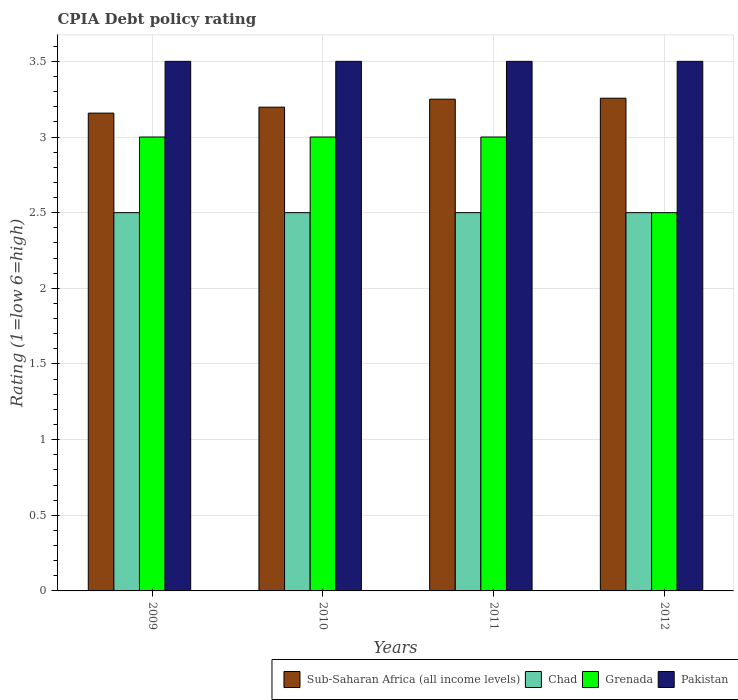What is the CPIA rating in Grenada in 2012?
Your answer should be compact. 2.5. Across all years, what is the maximum CPIA rating in Sub-Saharan Africa (all income levels)?
Offer a very short reply. 3.26. Across all years, what is the minimum CPIA rating in Sub-Saharan Africa (all income levels)?
Provide a succinct answer. 3.16. What is the difference between the CPIA rating in Sub-Saharan Africa (all income levels) in 2011 and that in 2012?
Ensure brevity in your answer.  -0.01. What is the average CPIA rating in Grenada per year?
Your response must be concise. 2.88. In the year 2012, what is the difference between the CPIA rating in Grenada and CPIA rating in Sub-Saharan Africa (all income levels)?
Your answer should be very brief. -0.76. What is the ratio of the CPIA rating in Sub-Saharan Africa (all income levels) in 2010 to that in 2012?
Keep it short and to the point. 0.98. Is the CPIA rating in Chad in 2010 less than that in 2012?
Give a very brief answer. No. Is the difference between the CPIA rating in Grenada in 2009 and 2012 greater than the difference between the CPIA rating in Sub-Saharan Africa (all income levels) in 2009 and 2012?
Ensure brevity in your answer.  Yes. What is the difference between the highest and the second highest CPIA rating in Sub-Saharan Africa (all income levels)?
Provide a short and direct response. 0.01. In how many years, is the CPIA rating in Pakistan greater than the average CPIA rating in Pakistan taken over all years?
Keep it short and to the point. 0. Is it the case that in every year, the sum of the CPIA rating in Grenada and CPIA rating in Chad is greater than the sum of CPIA rating in Sub-Saharan Africa (all income levels) and CPIA rating in Pakistan?
Offer a very short reply. No. What does the 3rd bar from the right in 2011 represents?
Your response must be concise. Chad. What is the difference between two consecutive major ticks on the Y-axis?
Ensure brevity in your answer.  0.5. How many legend labels are there?
Your answer should be compact. 4. How are the legend labels stacked?
Offer a terse response. Horizontal. What is the title of the graph?
Your answer should be very brief. CPIA Debt policy rating. Does "Small states" appear as one of the legend labels in the graph?
Provide a succinct answer. No. What is the label or title of the Y-axis?
Offer a terse response. Rating (1=low 6=high). What is the Rating (1=low 6=high) of Sub-Saharan Africa (all income levels) in 2009?
Your answer should be very brief. 3.16. What is the Rating (1=low 6=high) of Chad in 2009?
Offer a terse response. 2.5. What is the Rating (1=low 6=high) of Grenada in 2009?
Give a very brief answer. 3. What is the Rating (1=low 6=high) of Pakistan in 2009?
Your answer should be very brief. 3.5. What is the Rating (1=low 6=high) of Sub-Saharan Africa (all income levels) in 2010?
Your answer should be compact. 3.2. What is the Rating (1=low 6=high) in Grenada in 2010?
Your answer should be very brief. 3. What is the Rating (1=low 6=high) of Sub-Saharan Africa (all income levels) in 2011?
Provide a short and direct response. 3.25. What is the Rating (1=low 6=high) in Chad in 2011?
Your answer should be very brief. 2.5. What is the Rating (1=low 6=high) in Pakistan in 2011?
Provide a short and direct response. 3.5. What is the Rating (1=low 6=high) in Sub-Saharan Africa (all income levels) in 2012?
Offer a terse response. 3.26. Across all years, what is the maximum Rating (1=low 6=high) in Sub-Saharan Africa (all income levels)?
Offer a very short reply. 3.26. Across all years, what is the minimum Rating (1=low 6=high) in Sub-Saharan Africa (all income levels)?
Keep it short and to the point. 3.16. Across all years, what is the minimum Rating (1=low 6=high) in Chad?
Your answer should be compact. 2.5. Across all years, what is the minimum Rating (1=low 6=high) of Pakistan?
Provide a succinct answer. 3.5. What is the total Rating (1=low 6=high) in Sub-Saharan Africa (all income levels) in the graph?
Your response must be concise. 12.86. What is the difference between the Rating (1=low 6=high) in Sub-Saharan Africa (all income levels) in 2009 and that in 2010?
Your answer should be compact. -0.04. What is the difference between the Rating (1=low 6=high) in Pakistan in 2009 and that in 2010?
Ensure brevity in your answer.  0. What is the difference between the Rating (1=low 6=high) of Sub-Saharan Africa (all income levels) in 2009 and that in 2011?
Offer a terse response. -0.09. What is the difference between the Rating (1=low 6=high) of Grenada in 2009 and that in 2011?
Make the answer very short. 0. What is the difference between the Rating (1=low 6=high) in Pakistan in 2009 and that in 2011?
Your answer should be compact. 0. What is the difference between the Rating (1=low 6=high) of Sub-Saharan Africa (all income levels) in 2009 and that in 2012?
Provide a succinct answer. -0.1. What is the difference between the Rating (1=low 6=high) in Chad in 2009 and that in 2012?
Provide a short and direct response. 0. What is the difference between the Rating (1=low 6=high) of Grenada in 2009 and that in 2012?
Offer a very short reply. 0.5. What is the difference between the Rating (1=low 6=high) in Pakistan in 2009 and that in 2012?
Offer a terse response. 0. What is the difference between the Rating (1=low 6=high) of Sub-Saharan Africa (all income levels) in 2010 and that in 2011?
Offer a very short reply. -0.05. What is the difference between the Rating (1=low 6=high) of Chad in 2010 and that in 2011?
Your answer should be compact. 0. What is the difference between the Rating (1=low 6=high) in Grenada in 2010 and that in 2011?
Provide a short and direct response. 0. What is the difference between the Rating (1=low 6=high) of Sub-Saharan Africa (all income levels) in 2010 and that in 2012?
Keep it short and to the point. -0.06. What is the difference between the Rating (1=low 6=high) in Chad in 2010 and that in 2012?
Provide a succinct answer. 0. What is the difference between the Rating (1=low 6=high) of Grenada in 2010 and that in 2012?
Ensure brevity in your answer.  0.5. What is the difference between the Rating (1=low 6=high) of Pakistan in 2010 and that in 2012?
Make the answer very short. 0. What is the difference between the Rating (1=low 6=high) of Sub-Saharan Africa (all income levels) in 2011 and that in 2012?
Keep it short and to the point. -0.01. What is the difference between the Rating (1=low 6=high) of Pakistan in 2011 and that in 2012?
Give a very brief answer. 0. What is the difference between the Rating (1=low 6=high) in Sub-Saharan Africa (all income levels) in 2009 and the Rating (1=low 6=high) in Chad in 2010?
Offer a very short reply. 0.66. What is the difference between the Rating (1=low 6=high) of Sub-Saharan Africa (all income levels) in 2009 and the Rating (1=low 6=high) of Grenada in 2010?
Provide a succinct answer. 0.16. What is the difference between the Rating (1=low 6=high) of Sub-Saharan Africa (all income levels) in 2009 and the Rating (1=low 6=high) of Pakistan in 2010?
Provide a succinct answer. -0.34. What is the difference between the Rating (1=low 6=high) of Chad in 2009 and the Rating (1=low 6=high) of Grenada in 2010?
Your answer should be very brief. -0.5. What is the difference between the Rating (1=low 6=high) of Sub-Saharan Africa (all income levels) in 2009 and the Rating (1=low 6=high) of Chad in 2011?
Provide a succinct answer. 0.66. What is the difference between the Rating (1=low 6=high) of Sub-Saharan Africa (all income levels) in 2009 and the Rating (1=low 6=high) of Grenada in 2011?
Offer a very short reply. 0.16. What is the difference between the Rating (1=low 6=high) of Sub-Saharan Africa (all income levels) in 2009 and the Rating (1=low 6=high) of Pakistan in 2011?
Your response must be concise. -0.34. What is the difference between the Rating (1=low 6=high) of Chad in 2009 and the Rating (1=low 6=high) of Grenada in 2011?
Provide a short and direct response. -0.5. What is the difference between the Rating (1=low 6=high) of Grenada in 2009 and the Rating (1=low 6=high) of Pakistan in 2011?
Ensure brevity in your answer.  -0.5. What is the difference between the Rating (1=low 6=high) of Sub-Saharan Africa (all income levels) in 2009 and the Rating (1=low 6=high) of Chad in 2012?
Provide a short and direct response. 0.66. What is the difference between the Rating (1=low 6=high) in Sub-Saharan Africa (all income levels) in 2009 and the Rating (1=low 6=high) in Grenada in 2012?
Make the answer very short. 0.66. What is the difference between the Rating (1=low 6=high) in Sub-Saharan Africa (all income levels) in 2009 and the Rating (1=low 6=high) in Pakistan in 2012?
Your response must be concise. -0.34. What is the difference between the Rating (1=low 6=high) of Chad in 2009 and the Rating (1=low 6=high) of Pakistan in 2012?
Your answer should be compact. -1. What is the difference between the Rating (1=low 6=high) in Sub-Saharan Africa (all income levels) in 2010 and the Rating (1=low 6=high) in Chad in 2011?
Ensure brevity in your answer.  0.7. What is the difference between the Rating (1=low 6=high) in Sub-Saharan Africa (all income levels) in 2010 and the Rating (1=low 6=high) in Grenada in 2011?
Offer a very short reply. 0.2. What is the difference between the Rating (1=low 6=high) of Sub-Saharan Africa (all income levels) in 2010 and the Rating (1=low 6=high) of Pakistan in 2011?
Give a very brief answer. -0.3. What is the difference between the Rating (1=low 6=high) in Chad in 2010 and the Rating (1=low 6=high) in Grenada in 2011?
Provide a short and direct response. -0.5. What is the difference between the Rating (1=low 6=high) in Grenada in 2010 and the Rating (1=low 6=high) in Pakistan in 2011?
Your response must be concise. -0.5. What is the difference between the Rating (1=low 6=high) of Sub-Saharan Africa (all income levels) in 2010 and the Rating (1=low 6=high) of Chad in 2012?
Offer a very short reply. 0.7. What is the difference between the Rating (1=low 6=high) in Sub-Saharan Africa (all income levels) in 2010 and the Rating (1=low 6=high) in Grenada in 2012?
Ensure brevity in your answer.  0.7. What is the difference between the Rating (1=low 6=high) of Sub-Saharan Africa (all income levels) in 2010 and the Rating (1=low 6=high) of Pakistan in 2012?
Keep it short and to the point. -0.3. What is the difference between the Rating (1=low 6=high) in Chad in 2010 and the Rating (1=low 6=high) in Grenada in 2012?
Ensure brevity in your answer.  0. What is the difference between the Rating (1=low 6=high) of Chad in 2010 and the Rating (1=low 6=high) of Pakistan in 2012?
Keep it short and to the point. -1. What is the difference between the Rating (1=low 6=high) of Grenada in 2010 and the Rating (1=low 6=high) of Pakistan in 2012?
Your answer should be compact. -0.5. What is the difference between the Rating (1=low 6=high) in Chad in 2011 and the Rating (1=low 6=high) in Pakistan in 2012?
Your answer should be compact. -1. What is the difference between the Rating (1=low 6=high) of Grenada in 2011 and the Rating (1=low 6=high) of Pakistan in 2012?
Offer a very short reply. -0.5. What is the average Rating (1=low 6=high) in Sub-Saharan Africa (all income levels) per year?
Ensure brevity in your answer.  3.22. What is the average Rating (1=low 6=high) in Grenada per year?
Provide a short and direct response. 2.88. What is the average Rating (1=low 6=high) of Pakistan per year?
Your answer should be compact. 3.5. In the year 2009, what is the difference between the Rating (1=low 6=high) in Sub-Saharan Africa (all income levels) and Rating (1=low 6=high) in Chad?
Your response must be concise. 0.66. In the year 2009, what is the difference between the Rating (1=low 6=high) in Sub-Saharan Africa (all income levels) and Rating (1=low 6=high) in Grenada?
Keep it short and to the point. 0.16. In the year 2009, what is the difference between the Rating (1=low 6=high) of Sub-Saharan Africa (all income levels) and Rating (1=low 6=high) of Pakistan?
Provide a short and direct response. -0.34. In the year 2009, what is the difference between the Rating (1=low 6=high) in Chad and Rating (1=low 6=high) in Pakistan?
Ensure brevity in your answer.  -1. In the year 2009, what is the difference between the Rating (1=low 6=high) of Grenada and Rating (1=low 6=high) of Pakistan?
Your answer should be very brief. -0.5. In the year 2010, what is the difference between the Rating (1=low 6=high) in Sub-Saharan Africa (all income levels) and Rating (1=low 6=high) in Chad?
Ensure brevity in your answer.  0.7. In the year 2010, what is the difference between the Rating (1=low 6=high) in Sub-Saharan Africa (all income levels) and Rating (1=low 6=high) in Grenada?
Provide a short and direct response. 0.2. In the year 2010, what is the difference between the Rating (1=low 6=high) of Sub-Saharan Africa (all income levels) and Rating (1=low 6=high) of Pakistan?
Offer a terse response. -0.3. In the year 2010, what is the difference between the Rating (1=low 6=high) in Chad and Rating (1=low 6=high) in Grenada?
Make the answer very short. -0.5. In the year 2011, what is the difference between the Rating (1=low 6=high) of Sub-Saharan Africa (all income levels) and Rating (1=low 6=high) of Pakistan?
Keep it short and to the point. -0.25. In the year 2012, what is the difference between the Rating (1=low 6=high) of Sub-Saharan Africa (all income levels) and Rating (1=low 6=high) of Chad?
Provide a succinct answer. 0.76. In the year 2012, what is the difference between the Rating (1=low 6=high) in Sub-Saharan Africa (all income levels) and Rating (1=low 6=high) in Grenada?
Your answer should be very brief. 0.76. In the year 2012, what is the difference between the Rating (1=low 6=high) in Sub-Saharan Africa (all income levels) and Rating (1=low 6=high) in Pakistan?
Offer a terse response. -0.24. In the year 2012, what is the difference between the Rating (1=low 6=high) in Chad and Rating (1=low 6=high) in Grenada?
Provide a short and direct response. 0. What is the ratio of the Rating (1=low 6=high) of Chad in 2009 to that in 2010?
Your answer should be very brief. 1. What is the ratio of the Rating (1=low 6=high) of Grenada in 2009 to that in 2010?
Offer a very short reply. 1. What is the ratio of the Rating (1=low 6=high) of Sub-Saharan Africa (all income levels) in 2009 to that in 2011?
Offer a very short reply. 0.97. What is the ratio of the Rating (1=low 6=high) in Chad in 2009 to that in 2011?
Your answer should be compact. 1. What is the ratio of the Rating (1=low 6=high) in Grenada in 2009 to that in 2011?
Give a very brief answer. 1. What is the ratio of the Rating (1=low 6=high) of Pakistan in 2009 to that in 2011?
Offer a terse response. 1. What is the ratio of the Rating (1=low 6=high) in Sub-Saharan Africa (all income levels) in 2009 to that in 2012?
Your response must be concise. 0.97. What is the ratio of the Rating (1=low 6=high) in Chad in 2009 to that in 2012?
Provide a short and direct response. 1. What is the ratio of the Rating (1=low 6=high) of Sub-Saharan Africa (all income levels) in 2010 to that in 2011?
Provide a short and direct response. 0.98. What is the ratio of the Rating (1=low 6=high) in Grenada in 2010 to that in 2011?
Make the answer very short. 1. What is the ratio of the Rating (1=low 6=high) in Sub-Saharan Africa (all income levels) in 2010 to that in 2012?
Give a very brief answer. 0.98. What is the ratio of the Rating (1=low 6=high) of Sub-Saharan Africa (all income levels) in 2011 to that in 2012?
Give a very brief answer. 1. What is the ratio of the Rating (1=low 6=high) of Grenada in 2011 to that in 2012?
Offer a very short reply. 1.2. What is the ratio of the Rating (1=low 6=high) in Pakistan in 2011 to that in 2012?
Keep it short and to the point. 1. What is the difference between the highest and the second highest Rating (1=low 6=high) of Sub-Saharan Africa (all income levels)?
Keep it short and to the point. 0.01. What is the difference between the highest and the second highest Rating (1=low 6=high) of Grenada?
Offer a very short reply. 0. What is the difference between the highest and the lowest Rating (1=low 6=high) in Sub-Saharan Africa (all income levels)?
Your answer should be very brief. 0.1. What is the difference between the highest and the lowest Rating (1=low 6=high) of Chad?
Offer a terse response. 0. What is the difference between the highest and the lowest Rating (1=low 6=high) of Grenada?
Your answer should be very brief. 0.5. What is the difference between the highest and the lowest Rating (1=low 6=high) in Pakistan?
Offer a very short reply. 0. 